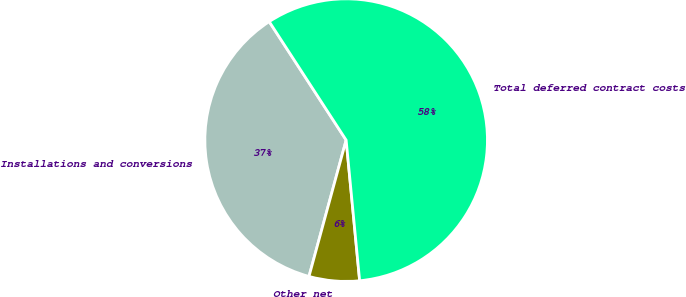<chart> <loc_0><loc_0><loc_500><loc_500><pie_chart><fcel>Installations and conversions<fcel>Other net<fcel>Total deferred contract costs<nl><fcel>36.6%<fcel>5.76%<fcel>57.64%<nl></chart> 